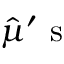<formula> <loc_0><loc_0><loc_500><loc_500>\hat { \mu } ^ { \prime } s</formula> 